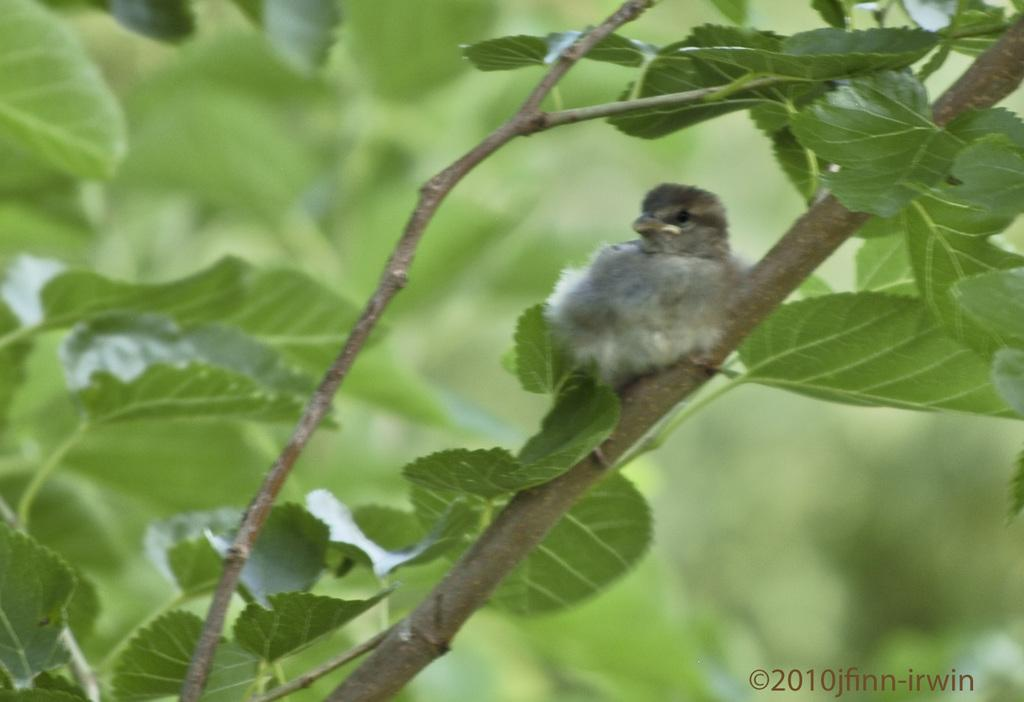What type of animal can be seen in the image? There is a bird in the image. Where is the bird located? The bird is sitting on a branch of a tree. What is written or printed at the bottom of the image? There is text printed at the bottom of the image. How would you describe the background of the image? The background of the image is blurred. What type of humor can be seen in the image? There is no humor present in the image; it features a bird sitting on a branch of a tree. Can you spot any rats in the image? There are no rats present in the image. 